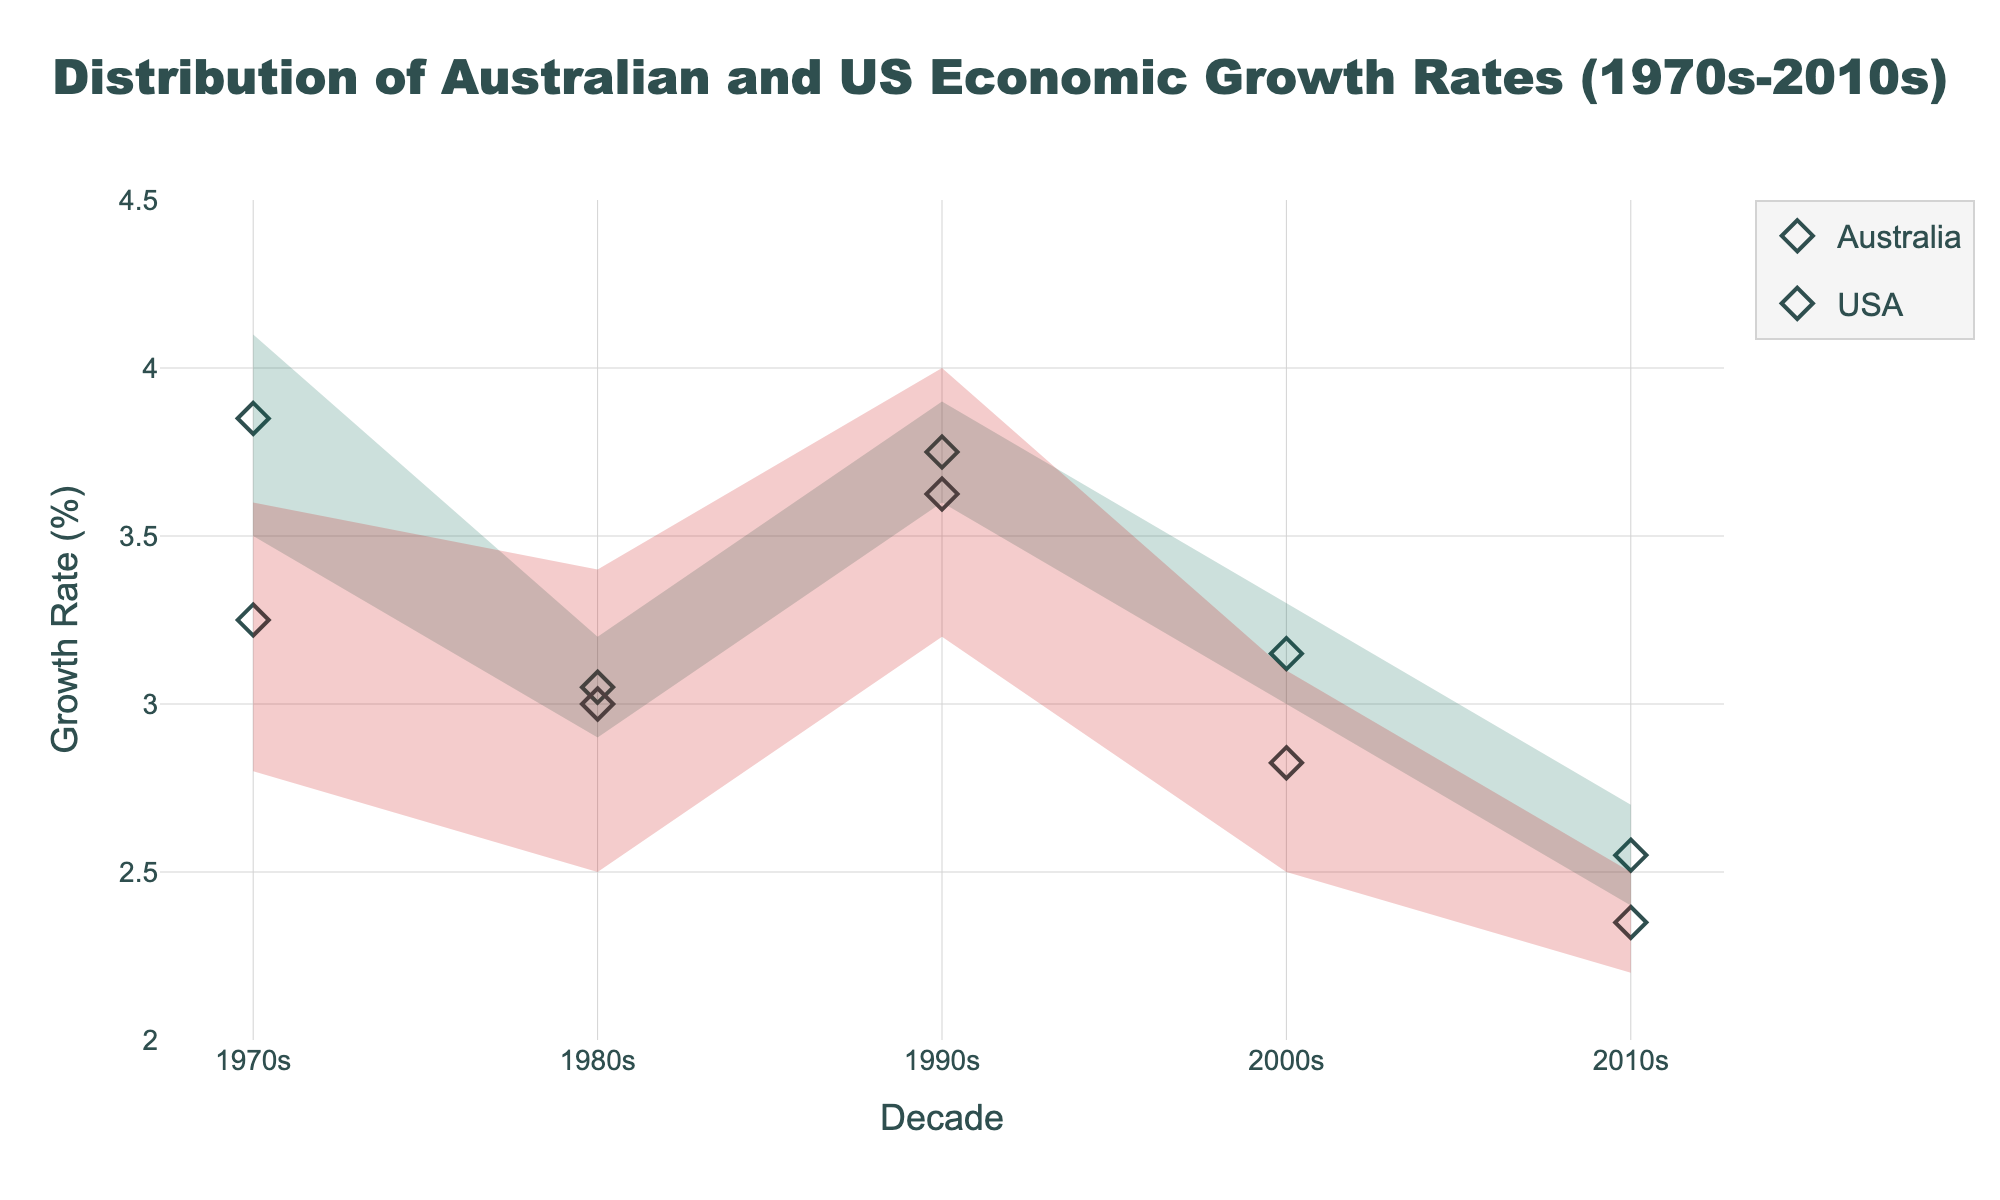What is the title of the plot? The title of the plot is typically positioned at the top of the graph. In this case, it reads: "Distribution of Australian and US Economic Growth Rates (1970s-2010s)"
Answer: Distribution of Australian and US Economic Growth Rates (1970s-2010s) What is the average growth rate for the US in the 1990s? The average growth rate for the US in the 1990s can be read directly from the visual's marker representing the mean for that range. The US's mean value marker for the 1990s shows 3.625.
Answer: 3.63 Which decade saw the lowest average growth rate for Australia? By examining the mean markers for Australia across all decades, the lowest average is seen in the 2010s with a value of 2.55.
Answer: 2010s Compare the average growth rates between Australia and the USA in the 1970s. The plot shows that the average growth rate for Australia in the 1970s is higher than that of the USA. Australia's average is approximately 3.85, whereas the USA's average is around 3.25.
Answer: Australia's growth rate was higher What is the highest recorded growth rate for the USA in the 2000s? The highest recorded growth rate for the USA in the 2000s can be identified from the upper end of the shaded range. It is at 3.1.
Answer: 3.1 During which decade did Australia and the US have the closest average growth rates? Comparing the mean markers for each decade reveals that the closest average growth rates between Australia and the USA occurred in the 1980s, with Australia at 3.05 and the USA at 3.00.
Answer: 1980s What was Australia's maximum growth rate in the 1990s? The maximum growth rate for Australia in the 1990s is shown at the upper end of the shaded area for that decade, which is 3.9.
Answer: 3.9 If you consider the range (Gap between Min and Max) of growth rates in the 2000s, which country shows more stability? By comparing the filled areas (ranges) in the 2000s, Australia has a narrower range from 3.0 to 3.3, while the USA's range is from 2.5 to 3.1. A narrower range indicates more stability; hence, Australia shows more stability.
Answer: Australia How did the economic growth rates of both countries change from the 1970s to the 2010s? To determine this, compare the mean markers in the 1970s versus the 2010s. Australia’s average went from approximately 3.85 in the 1970s to 2.55 in the 2010s, showing a decline. The US also declined from approximately 3.25 in the 1970s to 2.35 in the 2010s. Both countries experienced a decrease in growth rates.
Answer: Both declined What was the range of US growth rates in the 1980s? The range is the difference between the minimum and maximum values indicated. For the USA in the 1980s, the range spans from a minimum of 2.5 to a maximum of 3.4, making it 3.4 - 2.5 = 0.9.
Answer: 0.9 